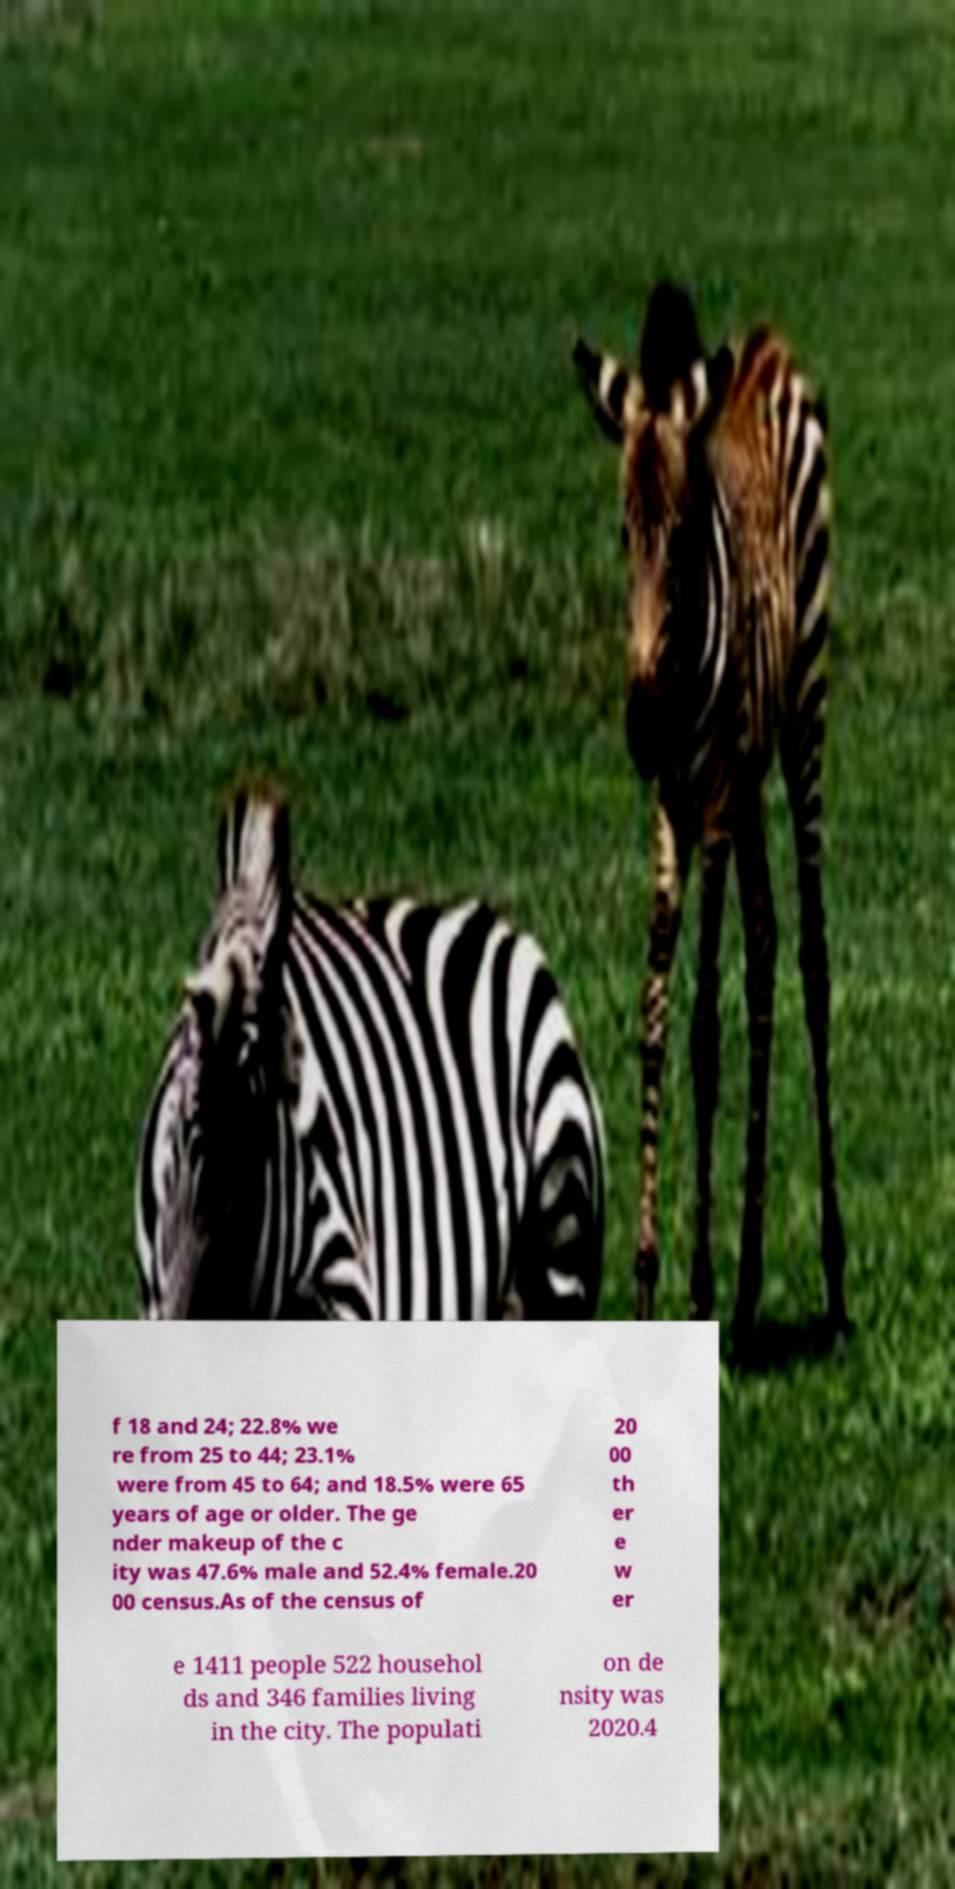Can you accurately transcribe the text from the provided image for me? f 18 and 24; 22.8% we re from 25 to 44; 23.1% were from 45 to 64; and 18.5% were 65 years of age or older. The ge nder makeup of the c ity was 47.6% male and 52.4% female.20 00 census.As of the census of 20 00 th er e w er e 1411 people 522 househol ds and 346 families living in the city. The populati on de nsity was 2020.4 